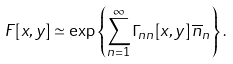<formula> <loc_0><loc_0><loc_500><loc_500>F [ x , y ] \simeq \exp \left \{ \sum _ { n = 1 } ^ { \infty } \Gamma _ { n n } [ x , y ] \, \overline { n } _ { n } \right \} .</formula> 